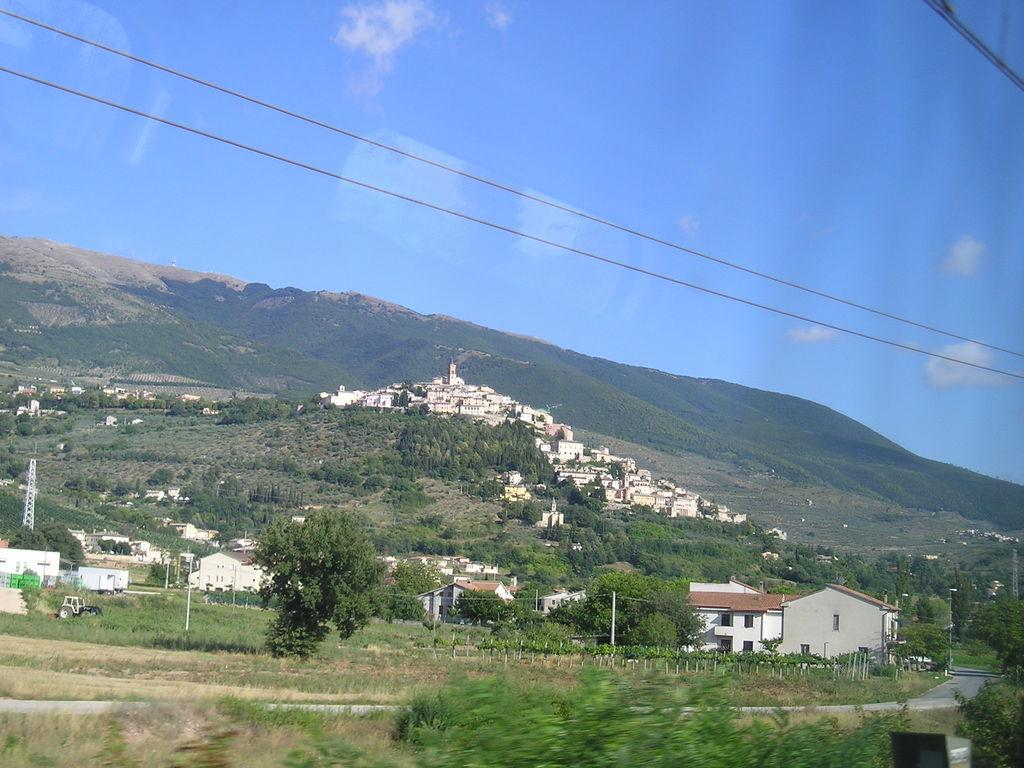What type of natural formation can be seen in the image? There are mountains in the image. What type of vegetation is present in the image? There are trees in the image. What type of man-made structures are visible in the image? There are houses in the image. What color is the sky in the image? The sky is blue in the image. Can you tell me where the beggar is located in the image? There is no beggar present in the image. What type of glass object is visible in the image? There is no glass object present in the image. 